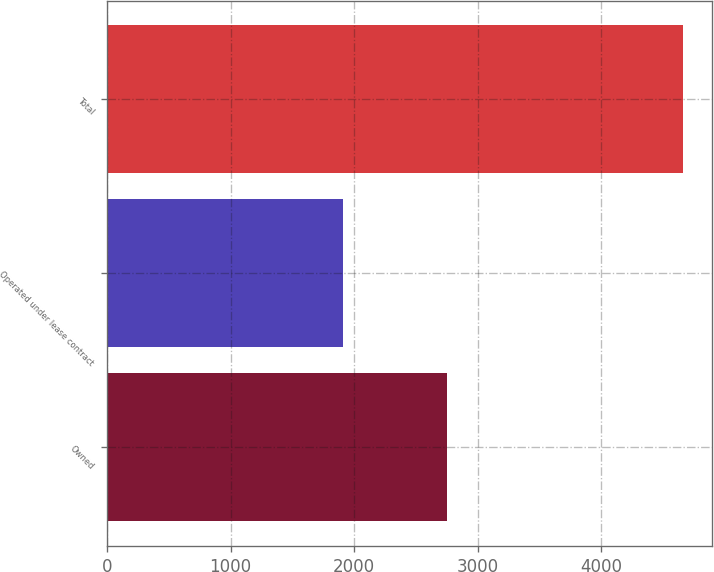Convert chart. <chart><loc_0><loc_0><loc_500><loc_500><bar_chart><fcel>Owned<fcel>Operated under lease contract<fcel>Total<nl><fcel>2750<fcel>1910<fcel>4660<nl></chart> 